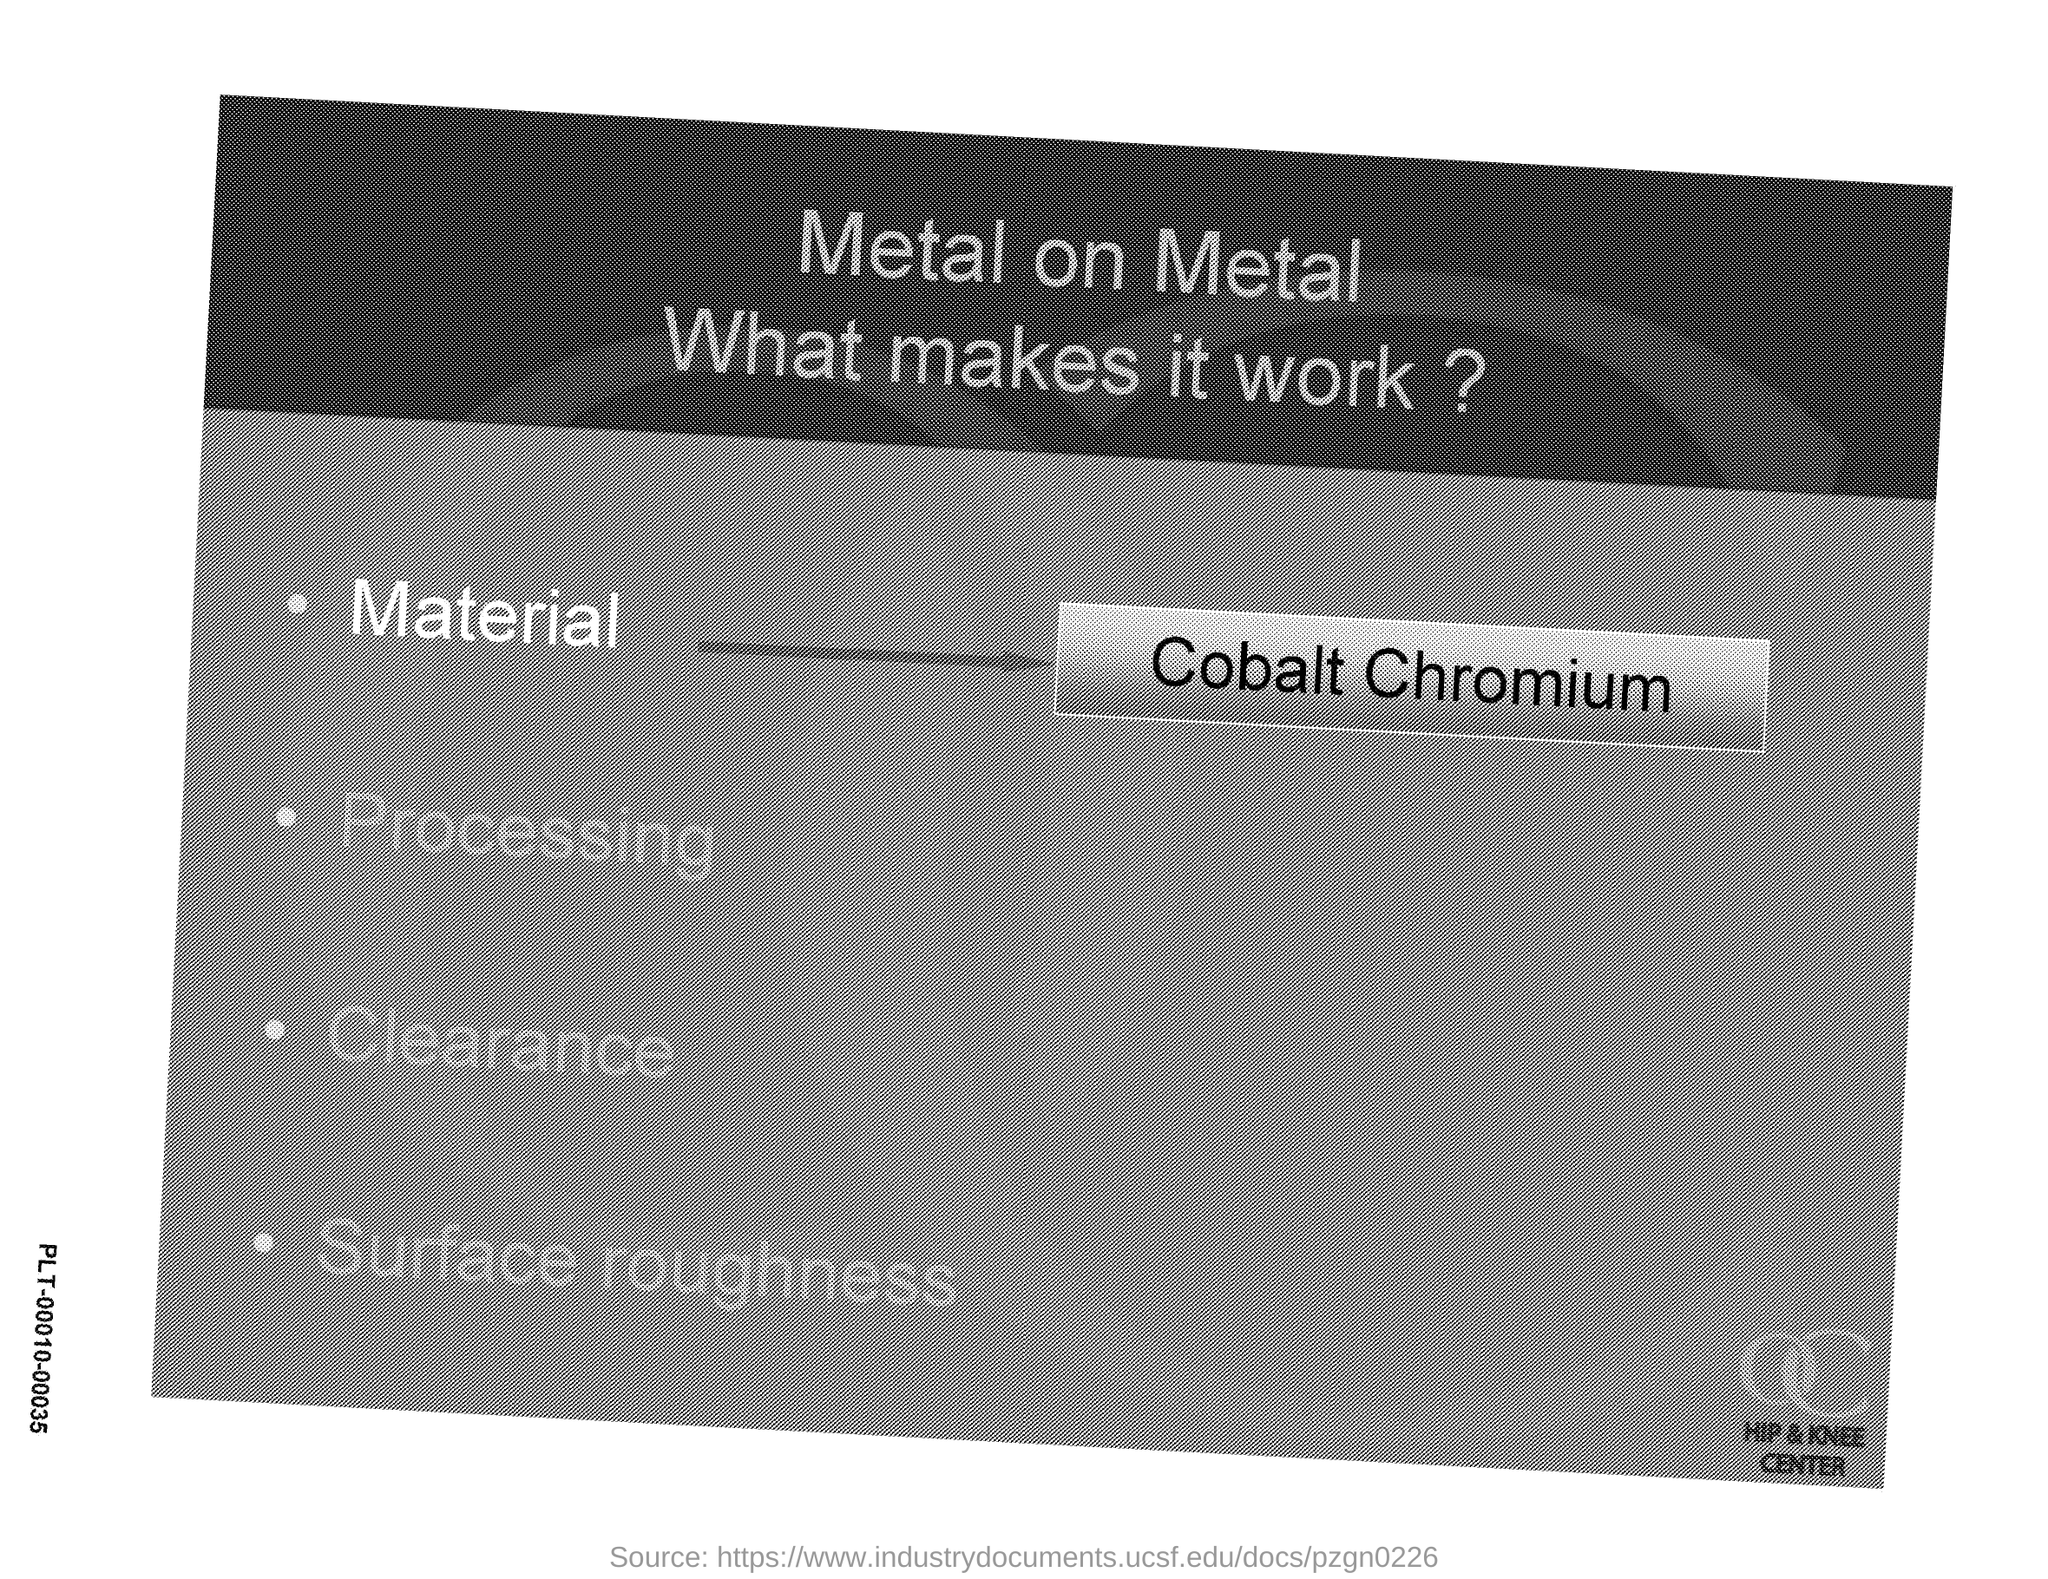Identify some key points in this picture. The material is called cobalt chromium. The topic is about metal on metal. 